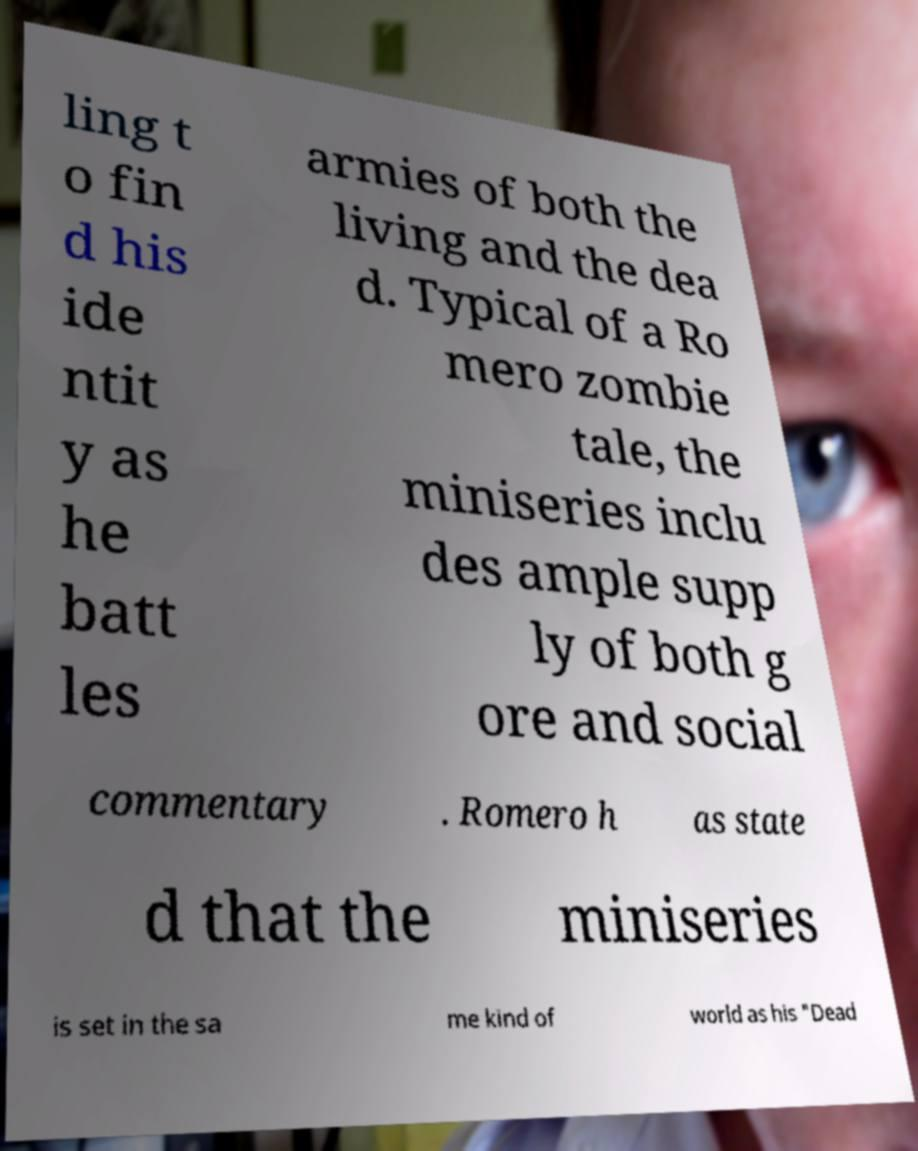Please identify and transcribe the text found in this image. ling t o fin d his ide ntit y as he batt les armies of both the living and the dea d. Typical of a Ro mero zombie tale, the miniseries inclu des ample supp ly of both g ore and social commentary . Romero h as state d that the miniseries is set in the sa me kind of world as his "Dead 